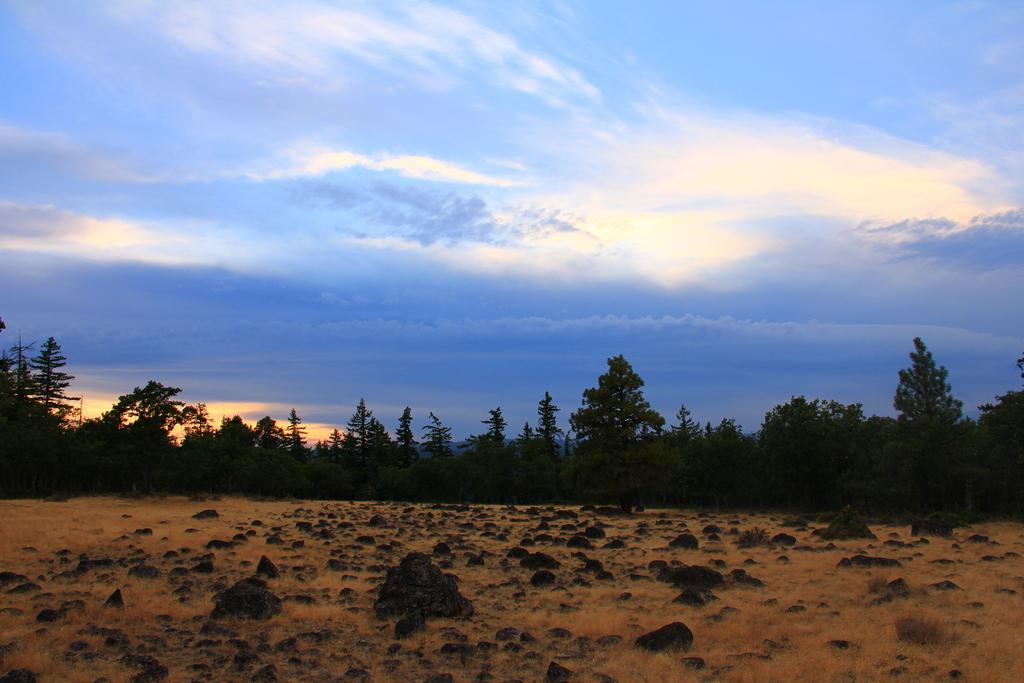What is the color of the sky in the background of the image? The sky in the background of the image is clear blue with clouds. What type of vegetation can be seen in the image? Trees are visible in the image. What is the general landscape depicted in the image? The image depicts a dried grassland area. What type of apparel is the grass wearing in the image? The grass in the image is not wearing any apparel, as it is a natural landscape feature. 